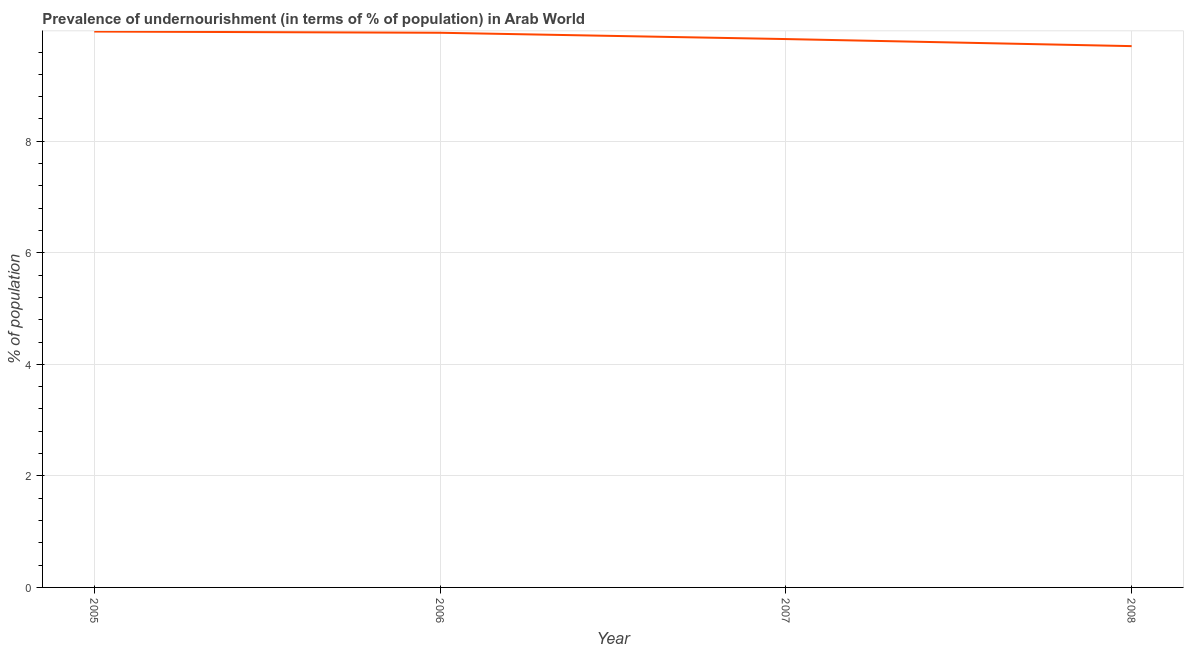What is the percentage of undernourished population in 2007?
Offer a terse response. 9.83. Across all years, what is the maximum percentage of undernourished population?
Provide a short and direct response. 9.97. Across all years, what is the minimum percentage of undernourished population?
Ensure brevity in your answer.  9.71. In which year was the percentage of undernourished population minimum?
Provide a succinct answer. 2008. What is the sum of the percentage of undernourished population?
Keep it short and to the point. 39.45. What is the difference between the percentage of undernourished population in 2006 and 2007?
Your answer should be very brief. 0.11. What is the average percentage of undernourished population per year?
Offer a very short reply. 9.86. What is the median percentage of undernourished population?
Offer a terse response. 9.89. In how many years, is the percentage of undernourished population greater than 8.4 %?
Offer a very short reply. 4. What is the ratio of the percentage of undernourished population in 2007 to that in 2008?
Keep it short and to the point. 1.01. Is the percentage of undernourished population in 2005 less than that in 2008?
Keep it short and to the point. No. What is the difference between the highest and the second highest percentage of undernourished population?
Keep it short and to the point. 0.02. What is the difference between the highest and the lowest percentage of undernourished population?
Make the answer very short. 0.26. How many lines are there?
Give a very brief answer. 1. What is the difference between two consecutive major ticks on the Y-axis?
Make the answer very short. 2. Are the values on the major ticks of Y-axis written in scientific E-notation?
Keep it short and to the point. No. Does the graph contain any zero values?
Your response must be concise. No. Does the graph contain grids?
Make the answer very short. Yes. What is the title of the graph?
Keep it short and to the point. Prevalence of undernourishment (in terms of % of population) in Arab World. What is the label or title of the Y-axis?
Make the answer very short. % of population. What is the % of population of 2005?
Your response must be concise. 9.97. What is the % of population of 2006?
Make the answer very short. 9.95. What is the % of population in 2007?
Your answer should be compact. 9.83. What is the % of population of 2008?
Your answer should be compact. 9.71. What is the difference between the % of population in 2005 and 2006?
Give a very brief answer. 0.02. What is the difference between the % of population in 2005 and 2007?
Provide a succinct answer. 0.13. What is the difference between the % of population in 2005 and 2008?
Your response must be concise. 0.26. What is the difference between the % of population in 2006 and 2007?
Offer a terse response. 0.11. What is the difference between the % of population in 2006 and 2008?
Make the answer very short. 0.24. What is the difference between the % of population in 2007 and 2008?
Your answer should be very brief. 0.13. What is the ratio of the % of population in 2005 to that in 2007?
Your response must be concise. 1.01. What is the ratio of the % of population in 2005 to that in 2008?
Your answer should be very brief. 1.03. What is the ratio of the % of population in 2006 to that in 2007?
Your answer should be very brief. 1.01. 